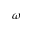Convert formula to latex. <formula><loc_0><loc_0><loc_500><loc_500>\omega</formula> 